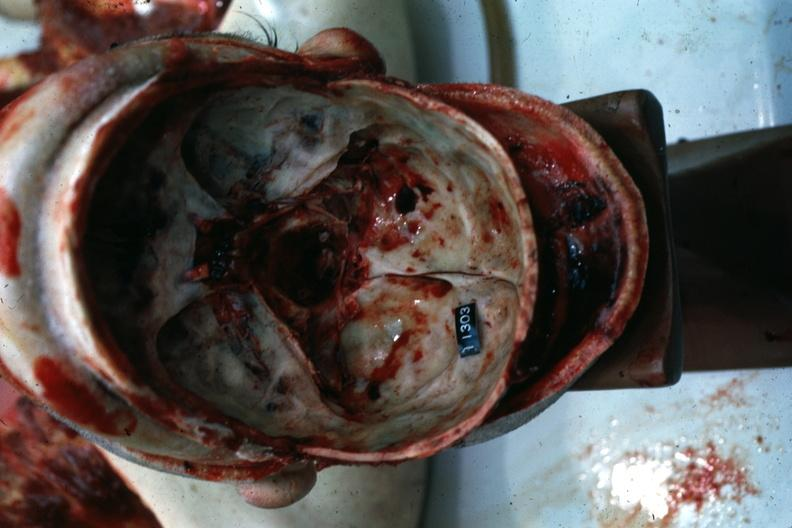does this image show multiple fractures?
Answer the question using a single word or phrase. Yes 